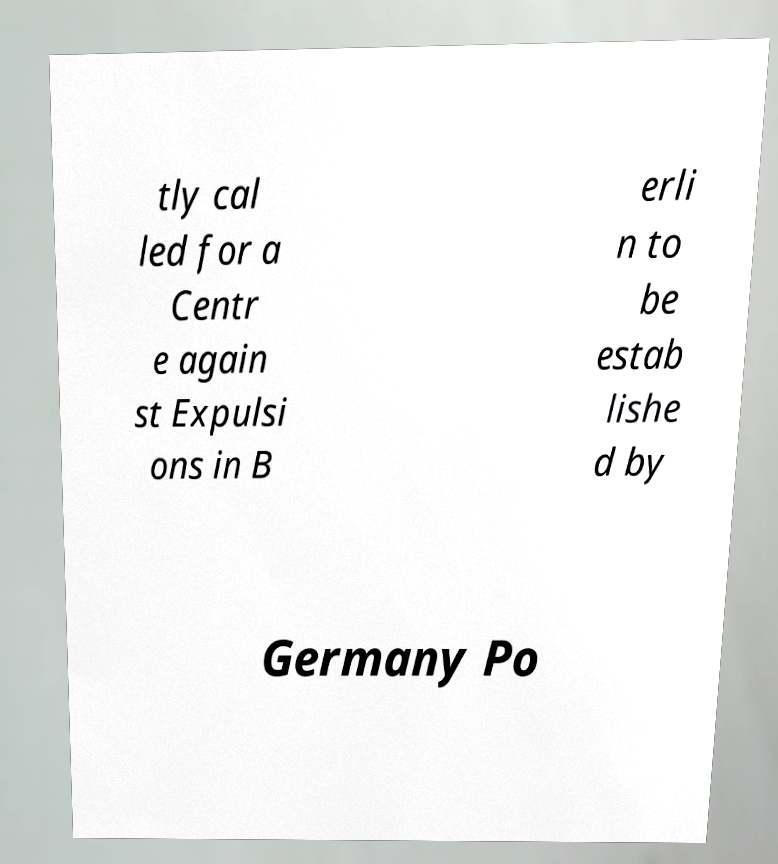Please identify and transcribe the text found in this image. tly cal led for a Centr e again st Expulsi ons in B erli n to be estab lishe d by Germany Po 